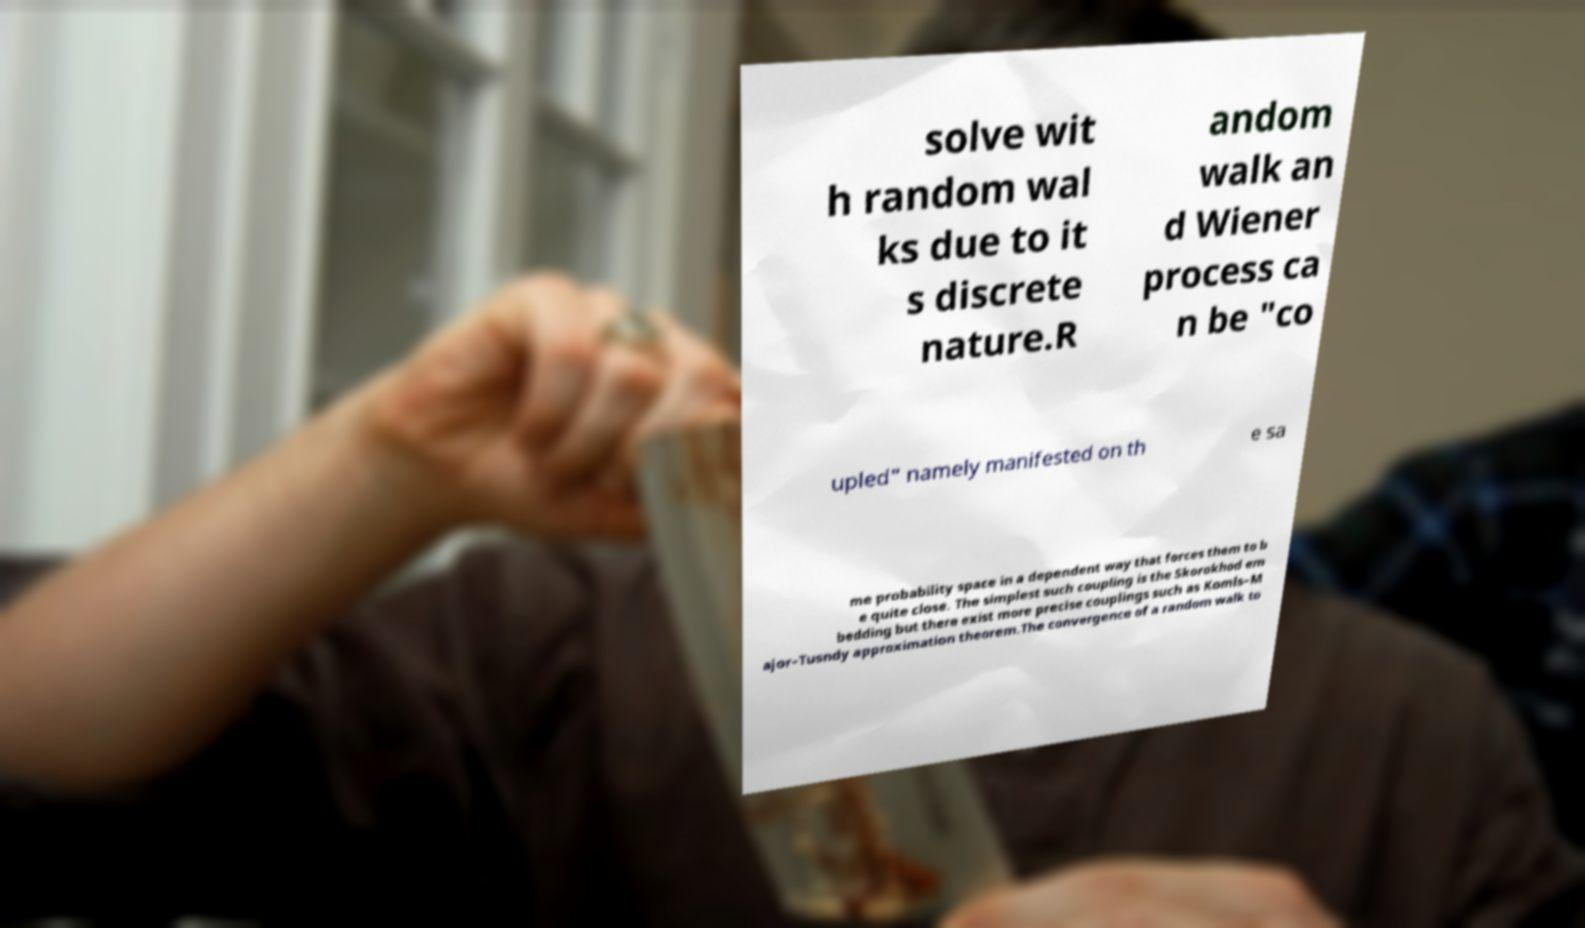Please read and relay the text visible in this image. What does it say? solve wit h random wal ks due to it s discrete nature.R andom walk an d Wiener process ca n be "co upled" namely manifested on th e sa me probability space in a dependent way that forces them to b e quite close. The simplest such coupling is the Skorokhod em bedding but there exist more precise couplings such as Komls–M ajor–Tusndy approximation theorem.The convergence of a random walk to 